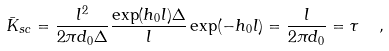Convert formula to latex. <formula><loc_0><loc_0><loc_500><loc_500>\bar { K } _ { s c } = \frac { l ^ { 2 } } { 2 \pi d _ { 0 } \Delta } \frac { \exp ( h _ { 0 } l ) \Delta } { l } \exp ( - h _ { 0 } l ) = \frac { l } { 2 \pi d _ { 0 } } = \tau \ \ ,</formula> 